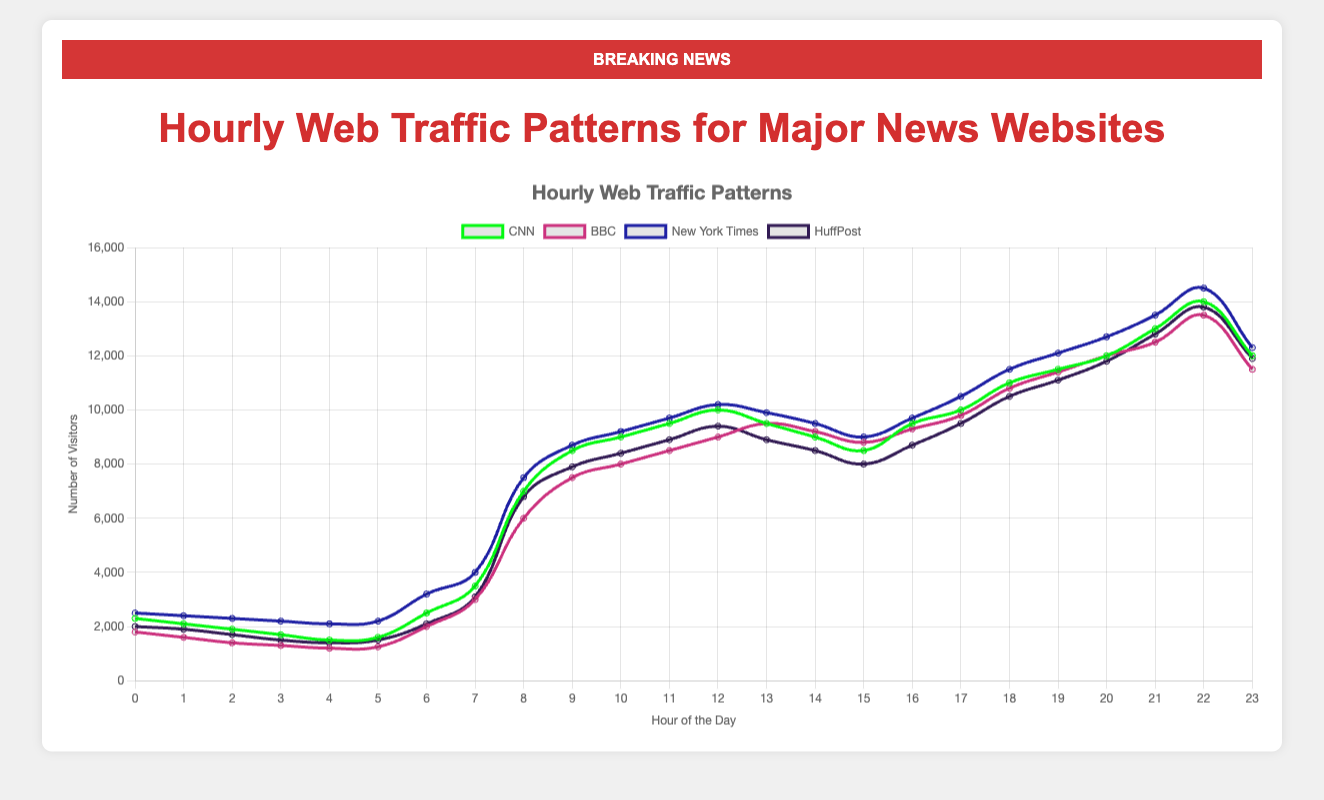Which website has the highest number of visitors at 10 PM? By looking at the figure, identify the curve that represents 10 PM (22:00) and find the highest peak at this time using the y-axis for visitors.
Answer: BBC What is the average number of visitors for CNN and BBC at 6 AM? Calculate the sum of visitors at 6 AM for both websites: CNN (2500) + BBC (2000), then divide the result by 2. (2500 + 2000) / 2 = 2250
Answer: 2250 Which website experiences the sharpest increase in visitors from 7 AM to 8 AM? Look at the slopes of the curves from 7 AM to 8 AM for each website. The steepest slope indicates the sharpest increase. The curve for CNN shows the largest increase jumping from 3500 to 7000.
Answer: CNN During which hours does the New York Times see the maximum visitors? Observe the curve representing the New York Times, identify the point with the highest peak, which occurs between 21:00 (13500 visitors) and 22:00 (14500 visitors). The highest value is at 22:00.
Answer: 10 PM What is the difference in visitors between HuffPost and CNN at their respective peak hours? Identify the peak hours for each: HuffPost at 10 PM (13800) and CNN at 10 PM (14000). Compute the absolute difference: 14000 - 13800 = 200
Answer: 200 Compare the visitors of BBC and New York Times at 1 PM. Which website has higher traffic? Refer to the figure to find the values at 1 PM: BBC (9500), New York Times (9900). New York Times has higher traffic.
Answer: New York Times What is the total number of visitors across all websites at 3 AM? Add the number of visitors for each website at 3 AM: CNN (1700), BBC (1300), New York Times (2200), HuffPost (1500). Total = 1700 + 1300 + 2200 + 1500 = 6700
Answer: 6700 At what hour does the traffic for HuffPost first surpass 10,000 visitors? Look for the first point where HuffPost's curve crosses the 10,000 visitor mark, which happens at 6 PM (18:00).
Answer: 6 PM How does the traffic of New York Times change between 2 AM and 4 AM? Identify the number of visitors at 2 AM (2300) and at 4 AM (2100) for New York Times. Calculate the difference: 2300 - 2100 = 200. It decreases by 200 visitors.
Answer: Decreases by 200 During which hours does BBC see the lowest web traffic? Check the curve for BBC and identify the lowest point in terms of visitors, which happens at 4 AM with 1200 visitors.
Answer: 4 AM 